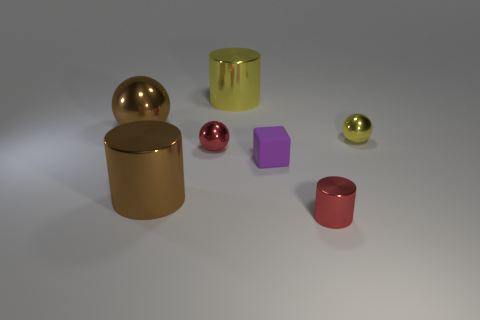Add 1 tiny gray cylinders. How many objects exist? 8 Subtract all cylinders. How many objects are left? 4 Subtract 0 blue balls. How many objects are left? 7 Subtract all large brown metal cylinders. Subtract all tiny metal cylinders. How many objects are left? 5 Add 1 red metallic things. How many red metallic things are left? 3 Add 4 tiny brown matte objects. How many tiny brown matte objects exist? 4 